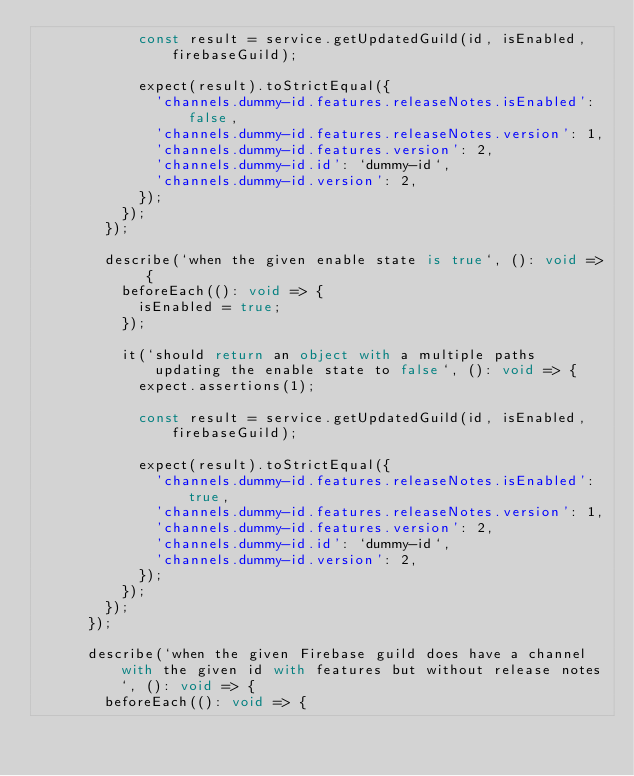<code> <loc_0><loc_0><loc_500><loc_500><_TypeScript_>            const result = service.getUpdatedGuild(id, isEnabled, firebaseGuild);

            expect(result).toStrictEqual({
              'channels.dummy-id.features.releaseNotes.isEnabled': false,
              'channels.dummy-id.features.releaseNotes.version': 1,
              'channels.dummy-id.features.version': 2,
              'channels.dummy-id.id': `dummy-id`,
              'channels.dummy-id.version': 2,
            });
          });
        });

        describe(`when the given enable state is true`, (): void => {
          beforeEach((): void => {
            isEnabled = true;
          });

          it(`should return an object with a multiple paths updating the enable state to false`, (): void => {
            expect.assertions(1);

            const result = service.getUpdatedGuild(id, isEnabled, firebaseGuild);

            expect(result).toStrictEqual({
              'channels.dummy-id.features.releaseNotes.isEnabled': true,
              'channels.dummy-id.features.releaseNotes.version': 1,
              'channels.dummy-id.features.version': 2,
              'channels.dummy-id.id': `dummy-id`,
              'channels.dummy-id.version': 2,
            });
          });
        });
      });

      describe(`when the given Firebase guild does have a channel with the given id with features but without release notes`, (): void => {
        beforeEach((): void => {</code> 